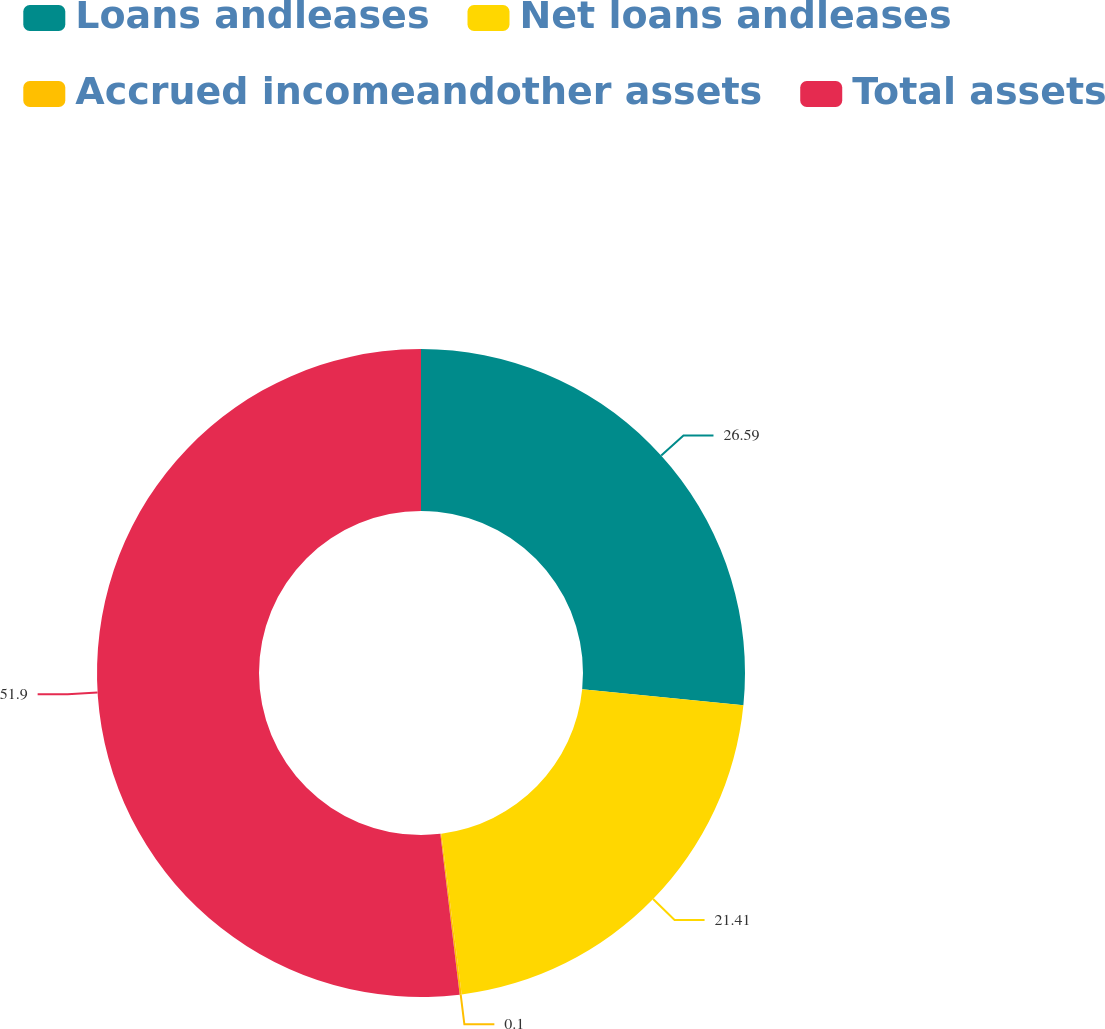Convert chart to OTSL. <chart><loc_0><loc_0><loc_500><loc_500><pie_chart><fcel>Loans andleases<fcel>Net loans andleases<fcel>Accrued incomeandother assets<fcel>Total assets<nl><fcel>26.59%<fcel>21.41%<fcel>0.1%<fcel>51.91%<nl></chart> 